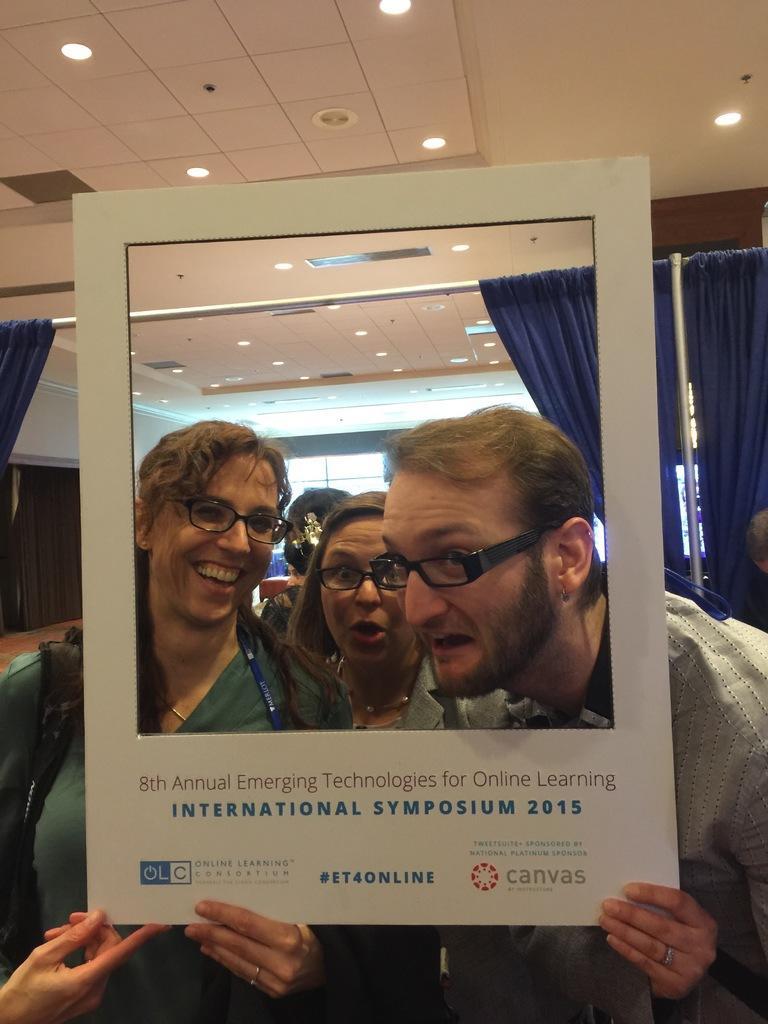In one or two sentences, can you explain what this image depicts? In this image there a few people standing and they are smiling. They are holding a board and there is text on the board. There are lights to the ceiling. There are curtains to a rod. In the background there are glass windows to the wall. 